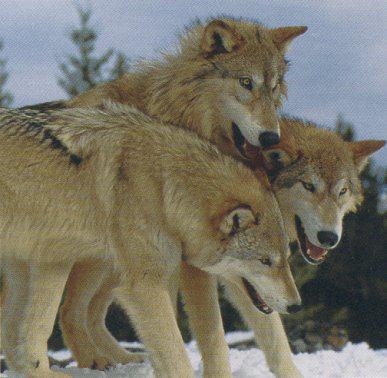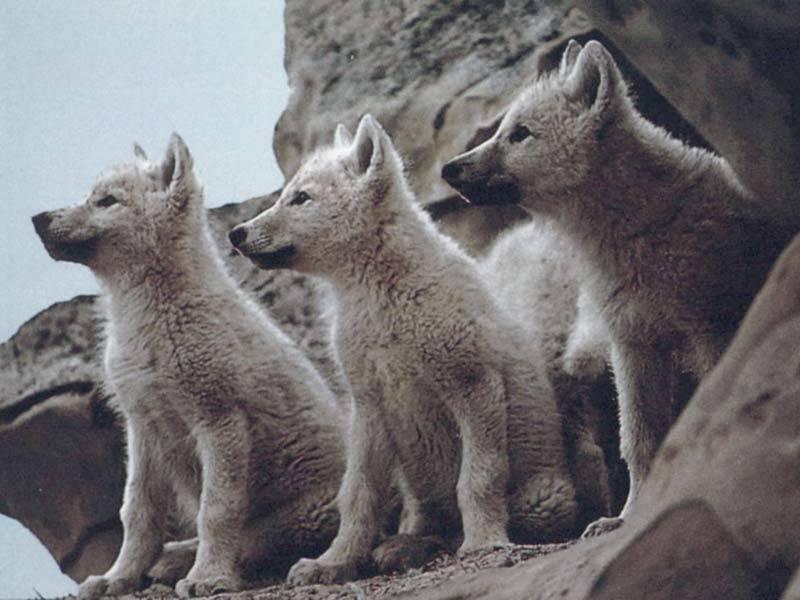The first image is the image on the left, the second image is the image on the right. Considering the images on both sides, is "there are 3 wolves huddled close on snowy ground in both pairs" valid? Answer yes or no. No. The first image is the image on the left, the second image is the image on the right. Examine the images to the left and right. Is the description "One image has three wolves without any snow." accurate? Answer yes or no. Yes. 